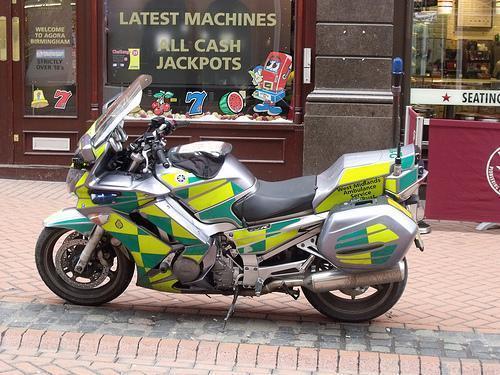How many motorcycles are there?
Give a very brief answer. 1. How many tires are in the image?
Give a very brief answer. 2. 